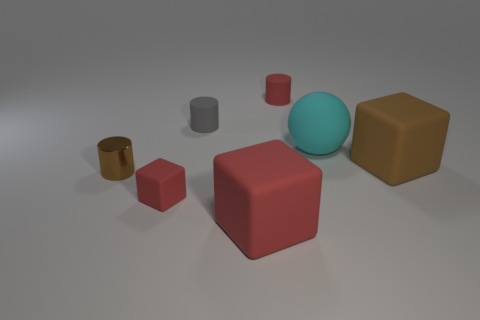Subtract all small rubber cylinders. How many cylinders are left? 1 Subtract all brown cylinders. How many cylinders are left? 2 Add 3 red things. How many objects exist? 10 Subtract 2 cylinders. How many cylinders are left? 1 Subtract all cylinders. How many objects are left? 4 Add 4 big cyan matte spheres. How many big cyan matte spheres are left? 5 Add 4 tiny rubber objects. How many tiny rubber objects exist? 7 Subtract 0 green cylinders. How many objects are left? 7 Subtract all yellow cylinders. Subtract all blue blocks. How many cylinders are left? 3 Subtract all gray cylinders. How many red cubes are left? 2 